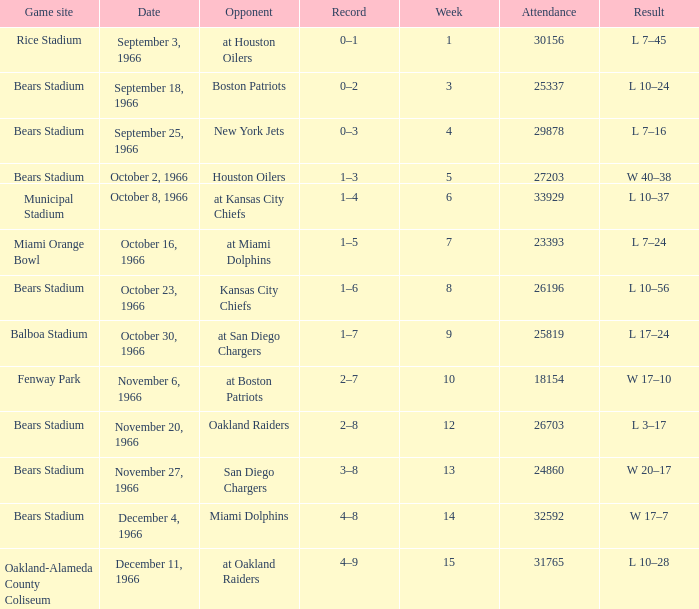How many results are listed for week 13? 1.0. Parse the full table. {'header': ['Game site', 'Date', 'Opponent', 'Record', 'Week', 'Attendance', 'Result'], 'rows': [['Rice Stadium', 'September 3, 1966', 'at Houston Oilers', '0–1', '1', '30156', 'L 7–45'], ['Bears Stadium', 'September 18, 1966', 'Boston Patriots', '0–2', '3', '25337', 'L 10–24'], ['Bears Stadium', 'September 25, 1966', 'New York Jets', '0–3', '4', '29878', 'L 7–16'], ['Bears Stadium', 'October 2, 1966', 'Houston Oilers', '1–3', '5', '27203', 'W 40–38'], ['Municipal Stadium', 'October 8, 1966', 'at Kansas City Chiefs', '1–4', '6', '33929', 'L 10–37'], ['Miami Orange Bowl', 'October 16, 1966', 'at Miami Dolphins', '1–5', '7', '23393', 'L 7–24'], ['Bears Stadium', 'October 23, 1966', 'Kansas City Chiefs', '1–6', '8', '26196', 'L 10–56'], ['Balboa Stadium', 'October 30, 1966', 'at San Diego Chargers', '1–7', '9', '25819', 'L 17–24'], ['Fenway Park', 'November 6, 1966', 'at Boston Patriots', '2–7', '10', '18154', 'W 17–10'], ['Bears Stadium', 'November 20, 1966', 'Oakland Raiders', '2–8', '12', '26703', 'L 3–17'], ['Bears Stadium', 'November 27, 1966', 'San Diego Chargers', '3–8', '13', '24860', 'W 20–17'], ['Bears Stadium', 'December 4, 1966', 'Miami Dolphins', '4–8', '14', '32592', 'W 17–7'], ['Oakland-Alameda County Coliseum', 'December 11, 1966', 'at Oakland Raiders', '4–9', '15', '31765', 'L 10–28']]} 